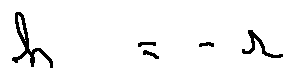Convert formula to latex. <formula><loc_0><loc_0><loc_500><loc_500>h = - r</formula> 